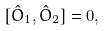Convert formula to latex. <formula><loc_0><loc_0><loc_500><loc_500>[ \hat { O } _ { 1 } , \hat { O } _ { 2 } ] = 0 ,</formula> 